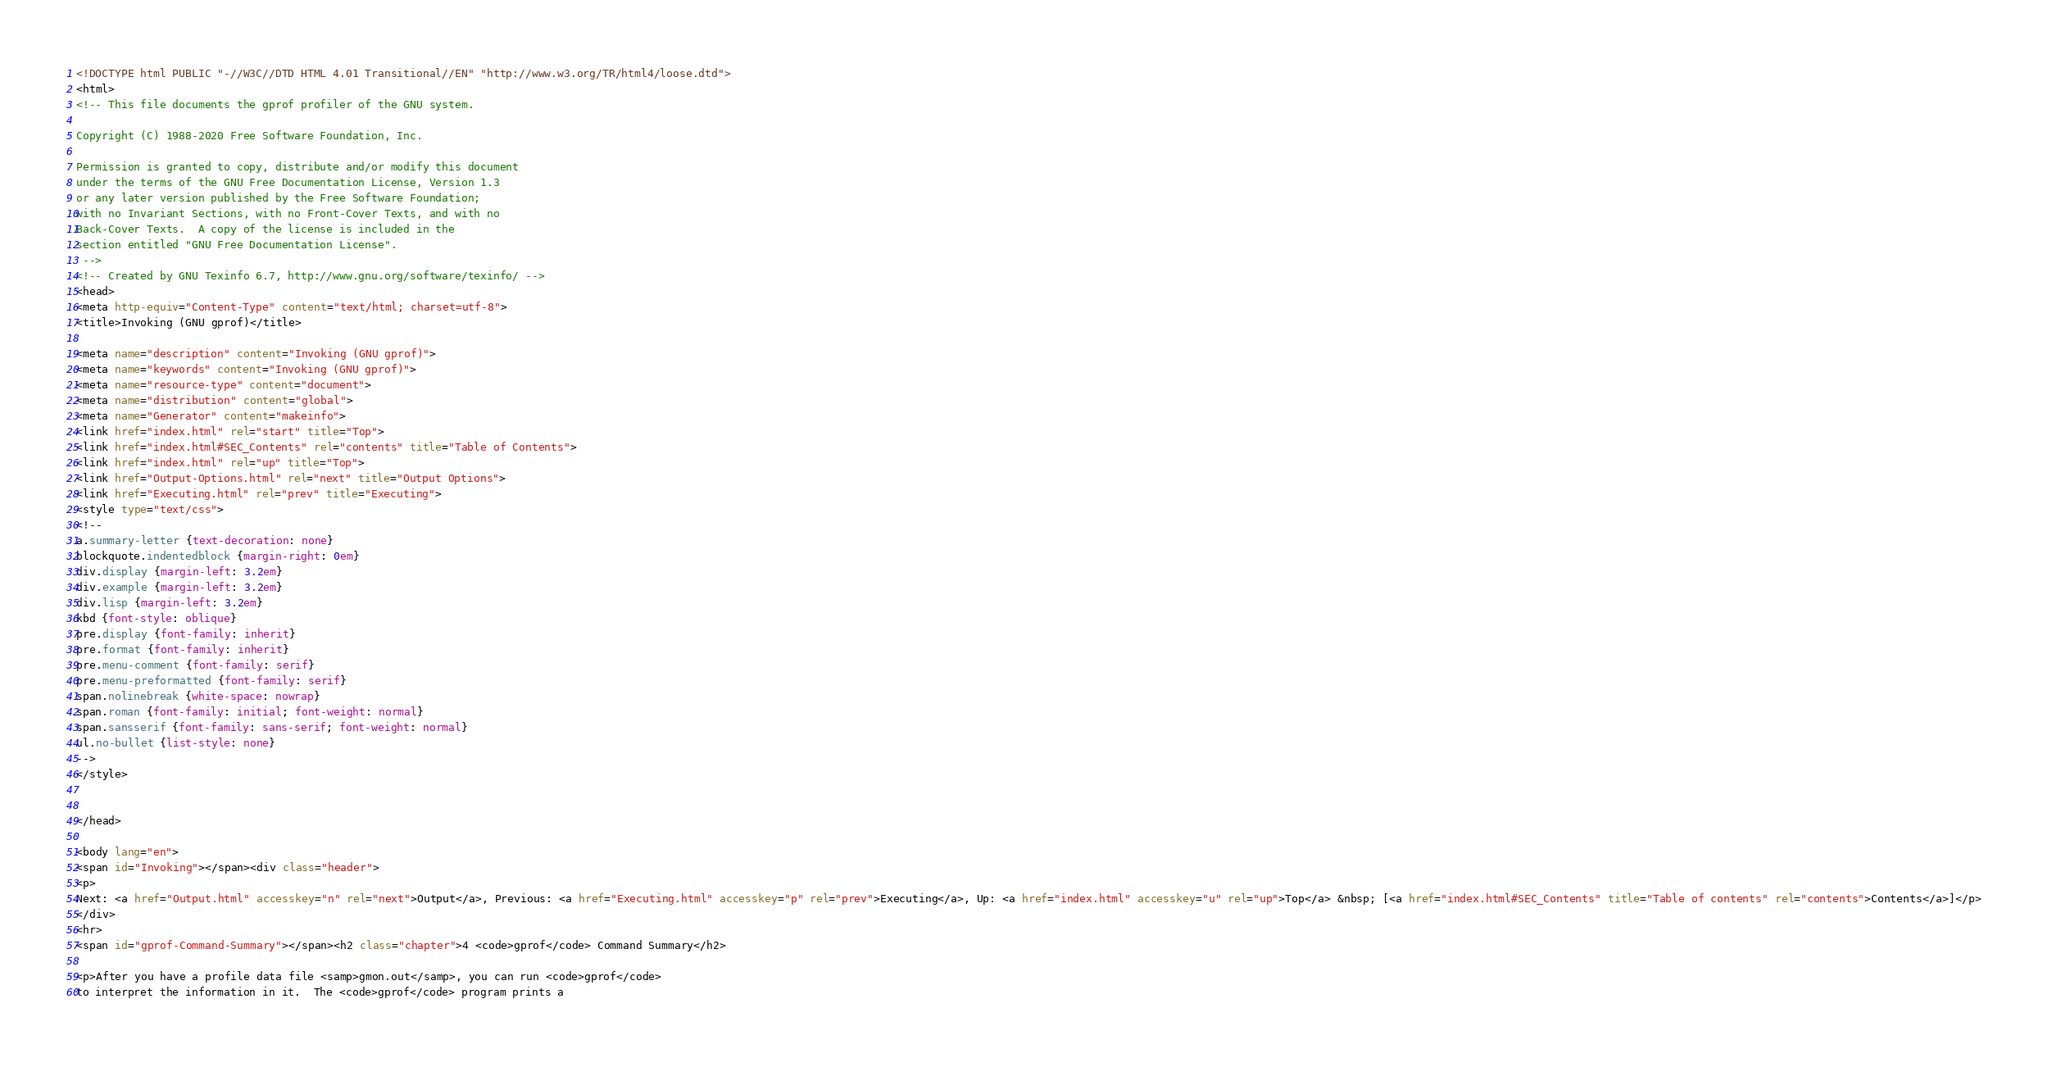<code> <loc_0><loc_0><loc_500><loc_500><_HTML_><!DOCTYPE html PUBLIC "-//W3C//DTD HTML 4.01 Transitional//EN" "http://www.w3.org/TR/html4/loose.dtd">
<html>
<!-- This file documents the gprof profiler of the GNU system.

Copyright (C) 1988-2020 Free Software Foundation, Inc.

Permission is granted to copy, distribute and/or modify this document
under the terms of the GNU Free Documentation License, Version 1.3
or any later version published by the Free Software Foundation;
with no Invariant Sections, with no Front-Cover Texts, and with no
Back-Cover Texts.  A copy of the license is included in the
section entitled "GNU Free Documentation License".
 -->
<!-- Created by GNU Texinfo 6.7, http://www.gnu.org/software/texinfo/ -->
<head>
<meta http-equiv="Content-Type" content="text/html; charset=utf-8">
<title>Invoking (GNU gprof)</title>

<meta name="description" content="Invoking (GNU gprof)">
<meta name="keywords" content="Invoking (GNU gprof)">
<meta name="resource-type" content="document">
<meta name="distribution" content="global">
<meta name="Generator" content="makeinfo">
<link href="index.html" rel="start" title="Top">
<link href="index.html#SEC_Contents" rel="contents" title="Table of Contents">
<link href="index.html" rel="up" title="Top">
<link href="Output-Options.html" rel="next" title="Output Options">
<link href="Executing.html" rel="prev" title="Executing">
<style type="text/css">
<!--
a.summary-letter {text-decoration: none}
blockquote.indentedblock {margin-right: 0em}
div.display {margin-left: 3.2em}
div.example {margin-left: 3.2em}
div.lisp {margin-left: 3.2em}
kbd {font-style: oblique}
pre.display {font-family: inherit}
pre.format {font-family: inherit}
pre.menu-comment {font-family: serif}
pre.menu-preformatted {font-family: serif}
span.nolinebreak {white-space: nowrap}
span.roman {font-family: initial; font-weight: normal}
span.sansserif {font-family: sans-serif; font-weight: normal}
ul.no-bullet {list-style: none}
-->
</style>


</head>

<body lang="en">
<span id="Invoking"></span><div class="header">
<p>
Next: <a href="Output.html" accesskey="n" rel="next">Output</a>, Previous: <a href="Executing.html" accesskey="p" rel="prev">Executing</a>, Up: <a href="index.html" accesskey="u" rel="up">Top</a> &nbsp; [<a href="index.html#SEC_Contents" title="Table of contents" rel="contents">Contents</a>]</p>
</div>
<hr>
<span id="gprof-Command-Summary"></span><h2 class="chapter">4 <code>gprof</code> Command Summary</h2>

<p>After you have a profile data file <samp>gmon.out</samp>, you can run <code>gprof</code>
to interpret the information in it.  The <code>gprof</code> program prints a</code> 